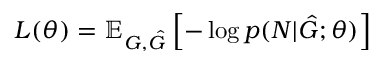<formula> <loc_0><loc_0><loc_500><loc_500>L ( \theta ) = \mathbb { E } _ { G , \hat { G } } \left [ - \log p ( N | \hat { G } ; \theta ) \right ]</formula> 